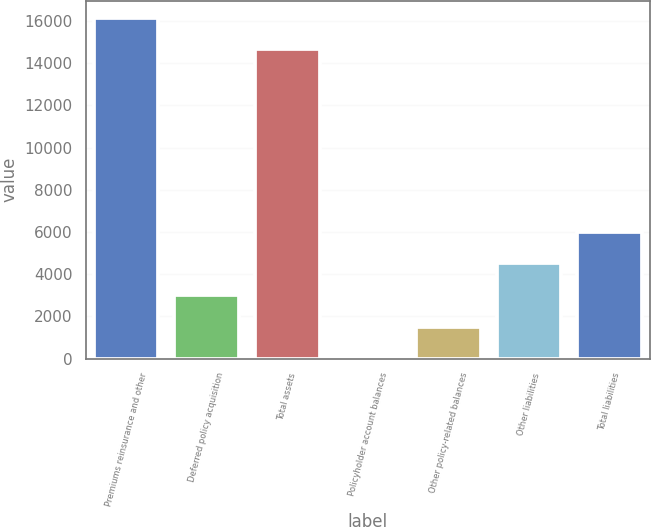<chart> <loc_0><loc_0><loc_500><loc_500><bar_chart><fcel>Premiums reinsurance and other<fcel>Deferred policy acquisition<fcel>Total assets<fcel>Policyholder account balances<fcel>Other policy-related balances<fcel>Other liabilities<fcel>Total liabilities<nl><fcel>16167.6<fcel>3005.2<fcel>14666<fcel>2<fcel>1503.6<fcel>4506.8<fcel>6008.4<nl></chart> 